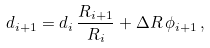<formula> <loc_0><loc_0><loc_500><loc_500>d _ { i + 1 } = d _ { i } \, \frac { R _ { i + 1 } } { R _ { i } } + \Delta R \, \phi _ { i + 1 } \, ,</formula> 